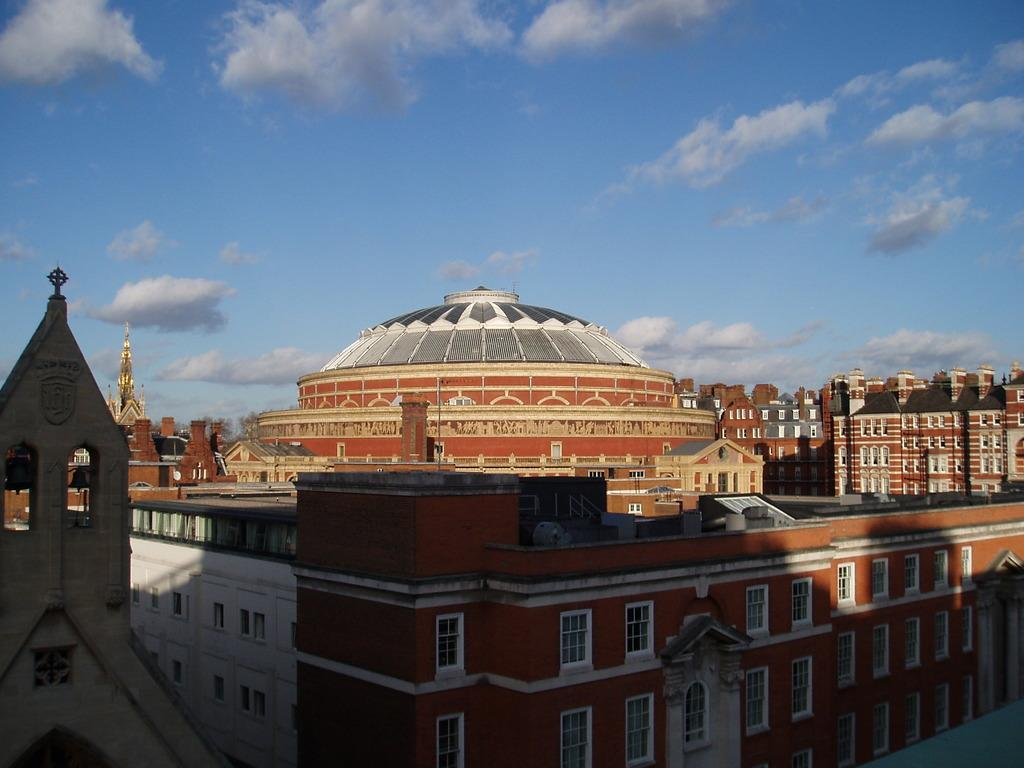What is the main subject in the foreground of the image? There is a big building in the foreground of the image. What can be seen in the background of the image? There are clouds in the sky in the background of the image. How many parcels are visible on the stove in the image? There is no stove or parcel present in the image. What type of dime is being used to pay for the building in the image? There is no dime or payment transaction depicted in the image. 